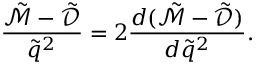<formula> <loc_0><loc_0><loc_500><loc_500>\frac { \tilde { \mathcal { M } } - \tilde { \mathcal { D } } } { \tilde { q } ^ { 2 } } = 2 \frac { d ( \tilde { \mathcal { M } } - \tilde { \mathcal { D } } ) } { d \tilde { q } ^ { 2 } } .</formula> 